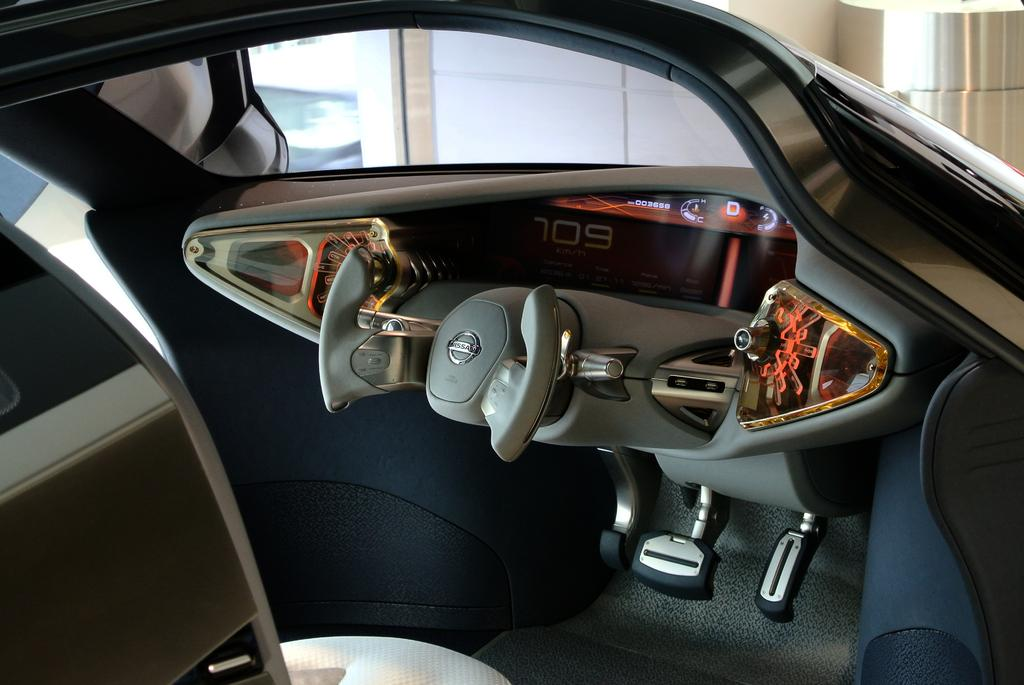What type of setting is depicted in the image? The image shows the inside view of a vehicle. What can be seen in the background of the image? There is a wall and a pillar visible in the background of the image. What type of stamp can be seen on the wall in the image? There is no stamp visible on the wall in the image. How many stems are present in the image? There are no stems present in the image. 